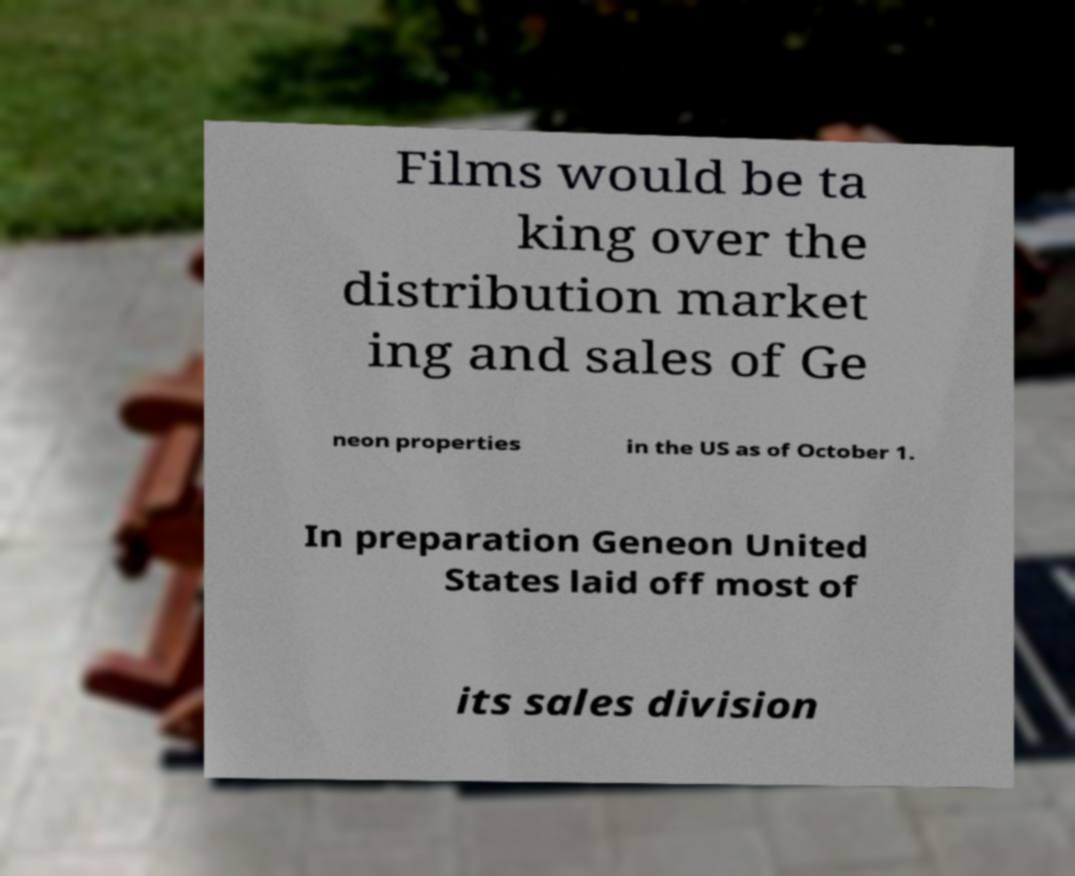Can you accurately transcribe the text from the provided image for me? Films would be ta king over the distribution market ing and sales of Ge neon properties in the US as of October 1. In preparation Geneon United States laid off most of its sales division 